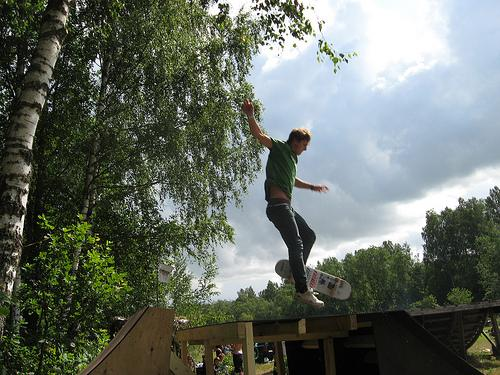Describe the personal accessory the skateboarder is wearing and its color. The skateboarder is wearing a silver watch on his wrist. How many objects can you perceive in this image, and what are their main features? Several objects: a man skateboarding, white sneakers, green shirt, wooden ramp, tree with green leaves, a birch tree trunk, people watching, and a cloudy sky. Analyze the image to provide information about the weather and the environment. The environment consists of tall green trees, a wooden ramp, and a cloudy sky with dark and white clouds. Examine the image and tell me about the skateboard's design and details. The skateboard has stickers on it, a white bottom, and yellow wheels. From the image, provide a detailed description of the skateboarder's attire. The skateboarder is wearing a green shirt, gray pants, white sneakers, and a silver watch on his wrist. Mention some noteworthy details about the trees surrounding the scene in the image. There is a large tree trunk, a birch tree with a white trunk, and green leaves on the trees, with moss growing on one. What is the primary activity happening in the image? A guy skateboarding and doing tricks on a wooden ramp. What are the people in the background doing while the skateboarder performs tricks? People in the background are watching the skateboarder and sitting on the grass. What type of footwear is the skateboarder wearing, and what color are the shoes? The skateboarder is wearing white sneakers. Identify the color and type of shirt the skateboarder is wearing in the image. The skateboarder is wearing a green, short sleeved tee shirt. Is the skateboarder holding a bottle of water in his hand? There is mention of "a stretched out arm", "mans wrist with watch" but no mention of a bottle in his hand. Asking for a bottle in the skateboarder's hand can mislead the viewer to search for an object that doesn't exist in the image. Are the skateboarder's pants orange? The instructions mention "a pair of gray pants" and "he is wearing jeans" but no mention of orange pants. This will mislead the viewer to look for orange pants which don't exist. Is there a pink hat on the skateboarder's head? There is mention of "a mans head" but no mention of a hat, let alone a pink one. This can lead the viewer to search for a hat that doesn't exist in the image.  Can you spot purple flowers in the background? There is mention of "tall green trees and leaves" and "tree with black and white trunk" but no mention of flowers, specifically purple ones. Asking for purple flowers will mislead the viewer to search for something that doesn't exist. Are there any red balloons in the sky? The details about the sky mention "a lot of clouds", "dark clouds", and "gray sky and white clouds" but there is no mention of balloons. Asking for red balloons in the sky will mislead viewers to search for something not present in the image. Are there any blue birds on the tree branches? There are details about "tree leaves", "moss growing on the tree", and "a large tree trunk" but no mention of birds. Asking for the presence of blue birds can lead the viewer to look for something not present in the image. 